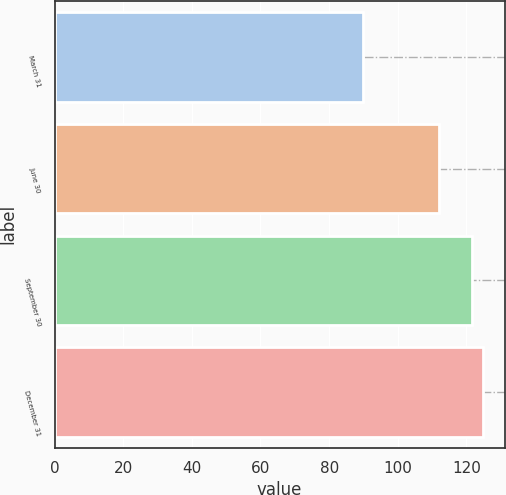Convert chart. <chart><loc_0><loc_0><loc_500><loc_500><bar_chart><fcel>March 31<fcel>June 30<fcel>September 30<fcel>December 31<nl><fcel>89.93<fcel>112<fcel>121.73<fcel>124.91<nl></chart> 